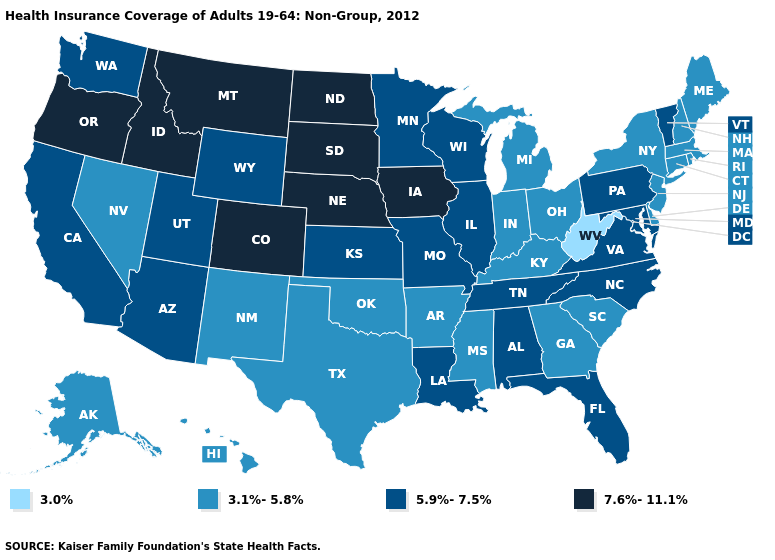What is the value of Illinois?
Short answer required. 5.9%-7.5%. Among the states that border Maryland , does West Virginia have the lowest value?
Concise answer only. Yes. Among the states that border Vermont , which have the highest value?
Quick response, please. Massachusetts, New Hampshire, New York. Among the states that border Idaho , does Montana have the highest value?
Concise answer only. Yes. Does Nevada have a higher value than Kansas?
Short answer required. No. Name the states that have a value in the range 5.9%-7.5%?
Answer briefly. Alabama, Arizona, California, Florida, Illinois, Kansas, Louisiana, Maryland, Minnesota, Missouri, North Carolina, Pennsylvania, Tennessee, Utah, Vermont, Virginia, Washington, Wisconsin, Wyoming. Does Missouri have the lowest value in the USA?
Short answer required. No. What is the value of New Mexico?
Give a very brief answer. 3.1%-5.8%. Among the states that border Kentucky , does Virginia have the lowest value?
Be succinct. No. What is the value of Georgia?
Be succinct. 3.1%-5.8%. Name the states that have a value in the range 7.6%-11.1%?
Concise answer only. Colorado, Idaho, Iowa, Montana, Nebraska, North Dakota, Oregon, South Dakota. What is the value of North Dakota?
Be succinct. 7.6%-11.1%. What is the lowest value in states that border Wyoming?
Give a very brief answer. 5.9%-7.5%. Among the states that border New Mexico , which have the lowest value?
Be succinct. Oklahoma, Texas. Name the states that have a value in the range 3.1%-5.8%?
Concise answer only. Alaska, Arkansas, Connecticut, Delaware, Georgia, Hawaii, Indiana, Kentucky, Maine, Massachusetts, Michigan, Mississippi, Nevada, New Hampshire, New Jersey, New Mexico, New York, Ohio, Oklahoma, Rhode Island, South Carolina, Texas. 